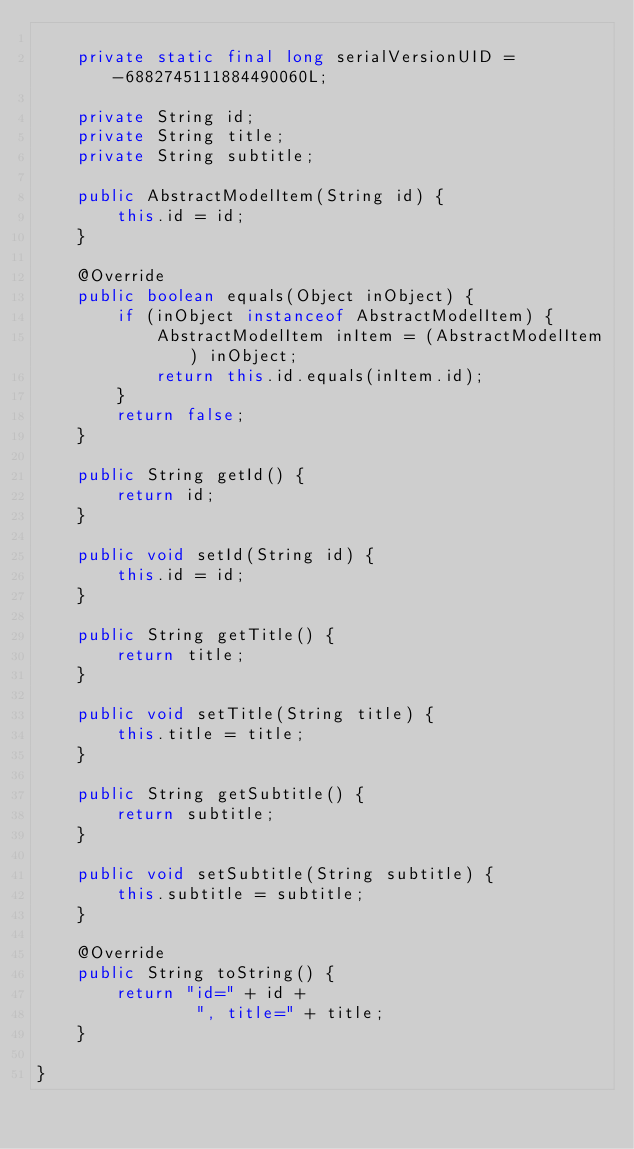<code> <loc_0><loc_0><loc_500><loc_500><_Java_>
	private static final long serialVersionUID = -6882745111884490060L;

	private String id;
	private String title;
	private String subtitle;

	public AbstractModelItem(String id) {
		this.id = id;
	}

	@Override
	public boolean equals(Object inObject) {
		if (inObject instanceof AbstractModelItem) {
			AbstractModelItem inItem = (AbstractModelItem) inObject;
			return this.id.equals(inItem.id);
		}
		return false;
	}

	public String getId() {
		return id;
	}

	public void setId(String id) {
		this.id = id;
	}

	public String getTitle() {
		return title;
	}

	public void setTitle(String title) {
		this.title = title;
	}

	public String getSubtitle() {
		return subtitle;
	}

	public void setSubtitle(String subtitle) {
		this.subtitle = subtitle;
	}

	@Override
	public String toString() {
		return "id=" + id +
				", title=" + title;
	}

}</code> 